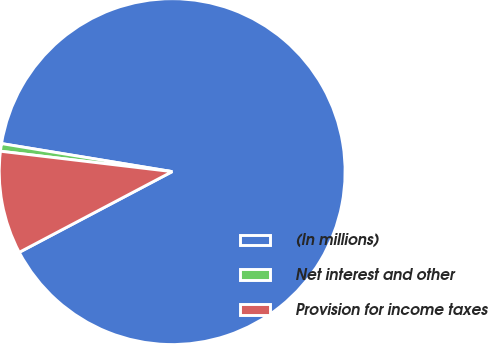<chart> <loc_0><loc_0><loc_500><loc_500><pie_chart><fcel>(In millions)<fcel>Net interest and other<fcel>Provision for income taxes<nl><fcel>89.68%<fcel>0.71%<fcel>9.61%<nl></chart> 